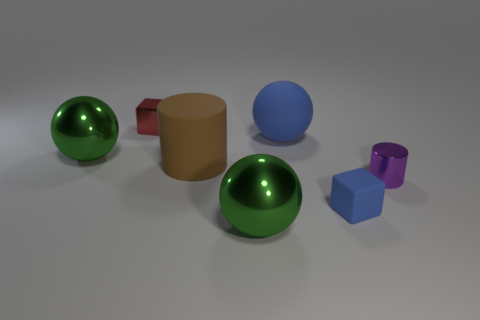There is a large thing that is the same color as the tiny matte cube; what shape is it?
Offer a terse response. Sphere. What number of metallic things are both on the left side of the blue matte ball and on the right side of the tiny blue object?
Provide a short and direct response. 0. Are there any other things that have the same color as the small matte object?
Give a very brief answer. Yes. How many rubber objects are either small purple cylinders or big green objects?
Provide a succinct answer. 0. There is a large sphere to the left of the brown thing behind the big green object in front of the tiny matte cube; what is its material?
Provide a succinct answer. Metal. There is a green ball behind the green shiny object that is in front of the tiny shiny cylinder; what is it made of?
Make the answer very short. Metal. Do the cylinder on the right side of the big brown matte cylinder and the green metallic object on the left side of the big brown object have the same size?
Your answer should be compact. No. Is there anything else that is made of the same material as the large brown thing?
Make the answer very short. Yes. What number of large objects are gray metallic things or blue spheres?
Provide a succinct answer. 1. What number of things are either blue rubber objects behind the rubber cylinder or rubber cubes?
Offer a terse response. 2. 